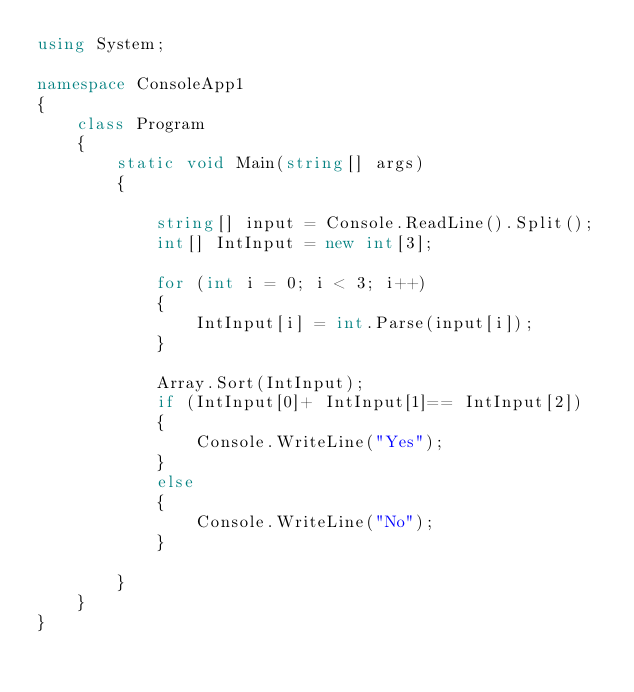Convert code to text. <code><loc_0><loc_0><loc_500><loc_500><_C#_>using System;

namespace ConsoleApp1
{
    class Program
    {
        static void Main(string[] args)
        {

            string[] input = Console.ReadLine().Split();
            int[] IntInput = new int[3];

            for (int i = 0; i < 3; i++)
            {
                IntInput[i] = int.Parse(input[i]);
            }

            Array.Sort(IntInput);
            if (IntInput[0]+ IntInput[1]== IntInput[2])
            {
                Console.WriteLine("Yes");
            }
            else
            {
                Console.WriteLine("No");
            }

        }
    }
}</code> 